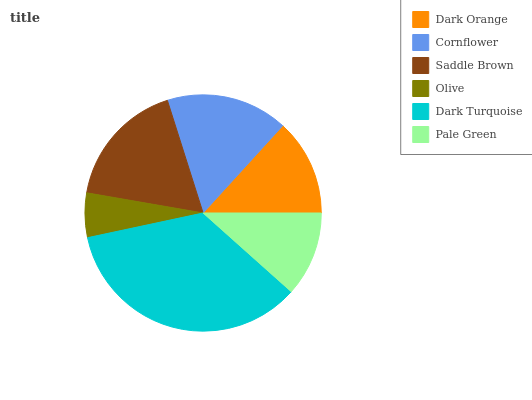Is Olive the minimum?
Answer yes or no. Yes. Is Dark Turquoise the maximum?
Answer yes or no. Yes. Is Cornflower the minimum?
Answer yes or no. No. Is Cornflower the maximum?
Answer yes or no. No. Is Cornflower greater than Dark Orange?
Answer yes or no. Yes. Is Dark Orange less than Cornflower?
Answer yes or no. Yes. Is Dark Orange greater than Cornflower?
Answer yes or no. No. Is Cornflower less than Dark Orange?
Answer yes or no. No. Is Cornflower the high median?
Answer yes or no. Yes. Is Dark Orange the low median?
Answer yes or no. Yes. Is Pale Green the high median?
Answer yes or no. No. Is Pale Green the low median?
Answer yes or no. No. 